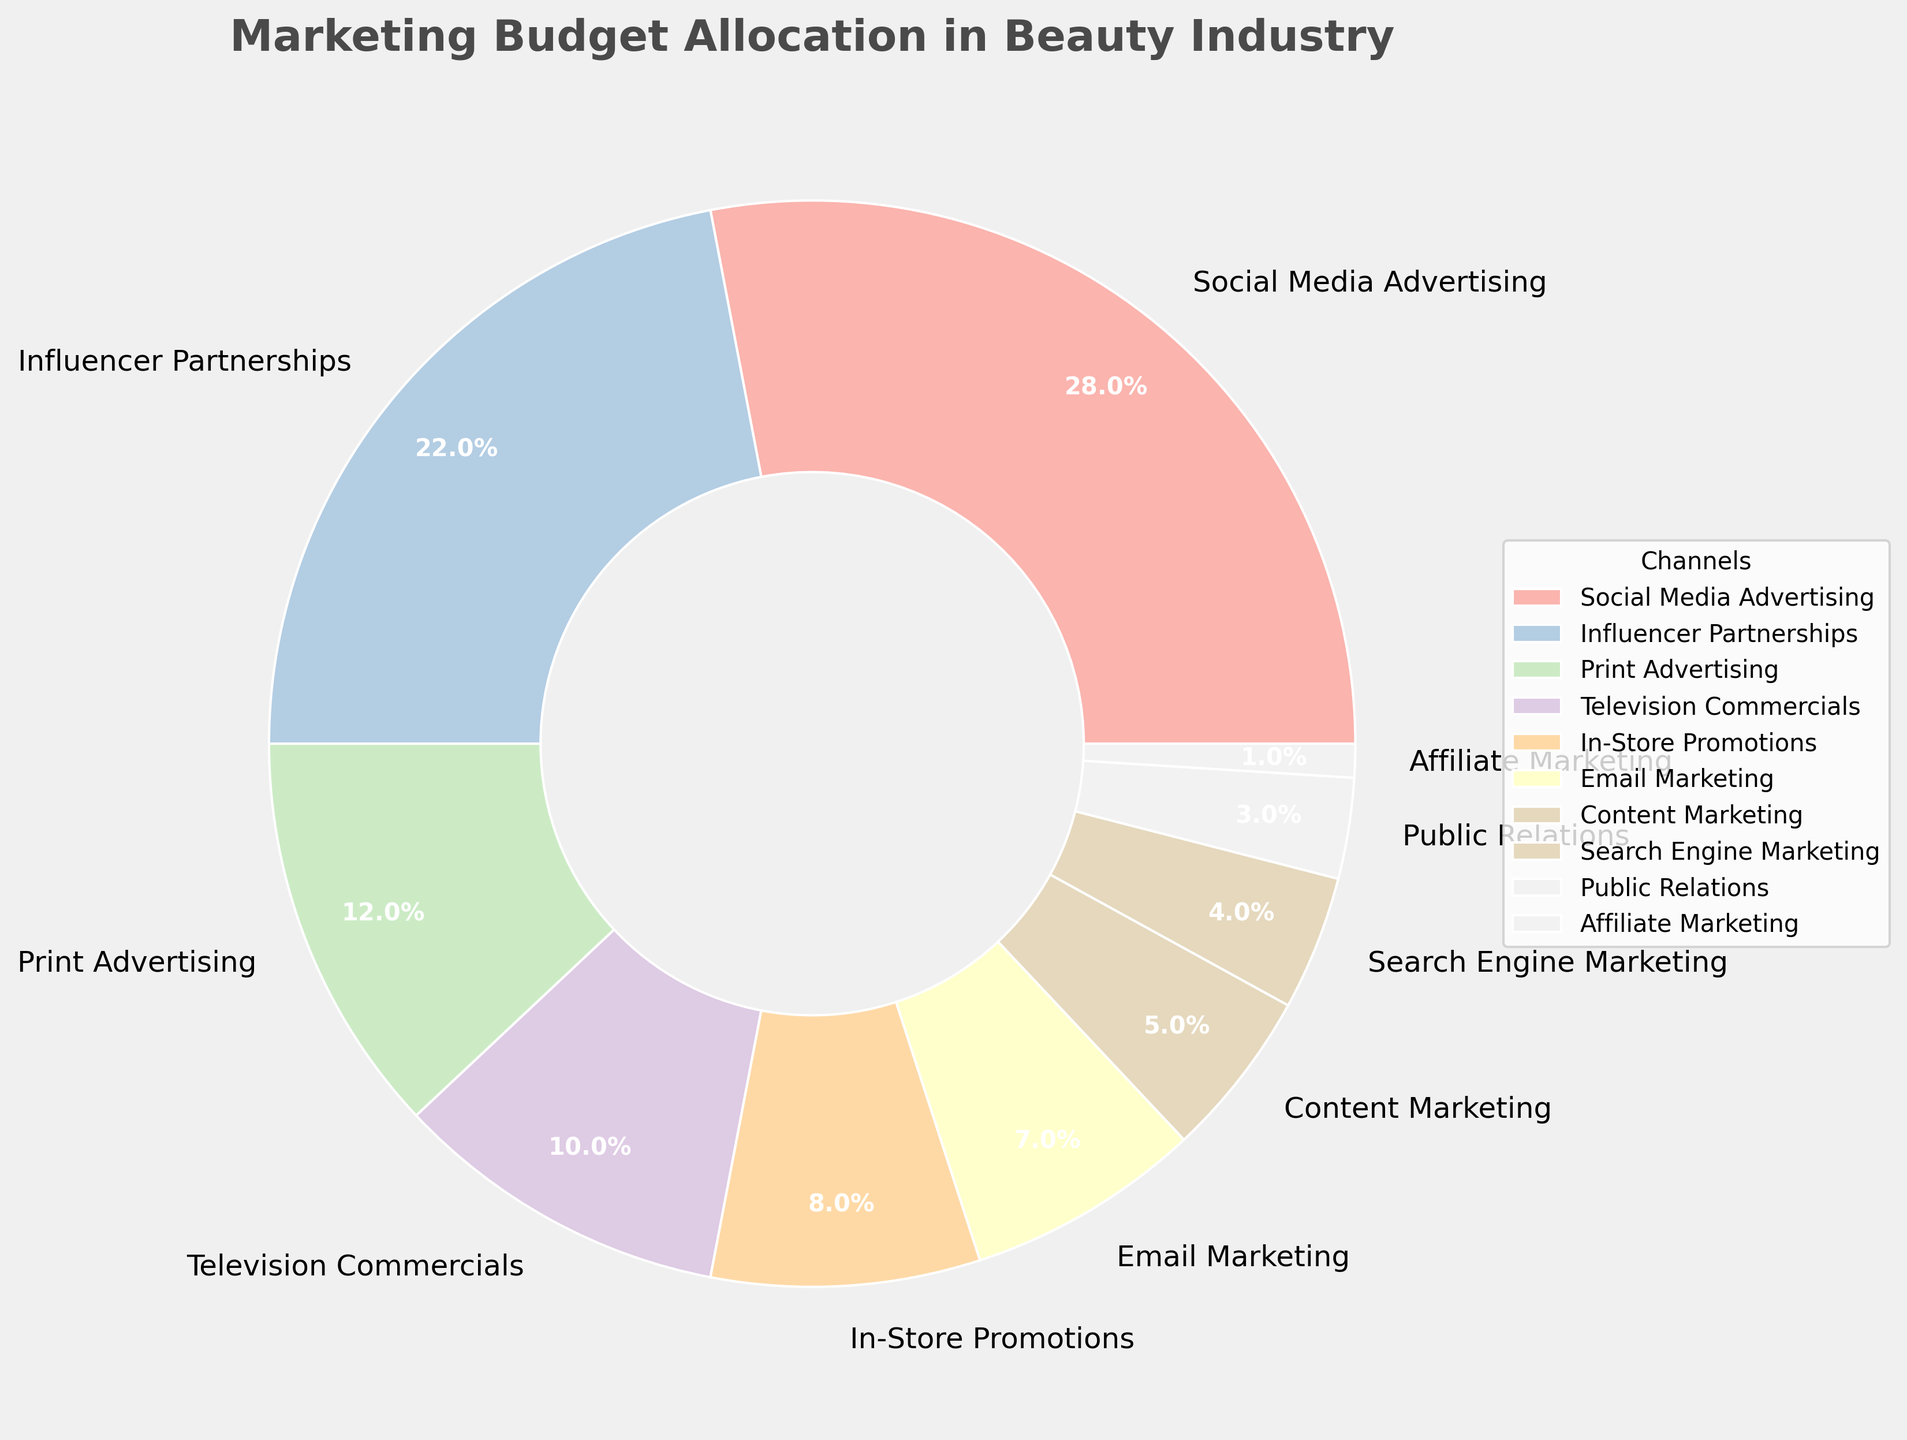Which promotional channel has the highest budget allocation? The promotional channel with the highest percentage in the pie chart is Social Media Advertising with 28%.
Answer: Social Media Advertising Which promotional channel has the lowest budget allocation? The promotional channel with the lowest percentage in the pie chart is Affiliate Marketing with 1%.
Answer: Affiliate Marketing What is the combined percentage for traditional advertising channels (Print Advertising and Television Commercials)? The percentage for Print Advertising is 12% and for Television Commercials is 10%. Summing them up gives 12% + 10% = 22%.
Answer: 22% How much more budget is allocated to Influencer Partnerships compared to In-Store Promotions? The percentage for Influencer Partnerships is 22% and for In-Store Promotions is 8%. The difference is 22% - 8% = 14%.
Answer: 14% Which channel, Content Marketing or Search Engine Marketing, has a higher budget allocation, and by how much? Content Marketing has 5%, and Search Engine Marketing has 4%. The difference is 5% - 4% = 1%. Hence, Content Marketing has a higher allocation by 1%.
Answer: Content Marketing by 1% What percentage of the marketing budget is allocated to digital channels (Social Media Advertising, Influencer Partnerships, Email Marketing, Content Marketing, Search Engine Marketing, and Affiliate Marketing)? Adding the percentages: 28% (Social Media Advertising) + 22% (Influencer Partnerships) + 7% (Email Marketing) + 5% (Content Marketing) + 4% (Search Engine Marketing) + 1% (Affiliate Marketing) = 67%.
Answer: 67% Are there more budget allocations for Digital Marketing channels compared to Traditional Marketing (Print Advertising, Television Commercials, In-Store Promotions, Public Relations)? Adding percentages for Digital Marketing (67%) and Traditional Marketing: 12% (Print Advertising) + 10% (Television Commercials) + 8% (In-Store Promotions) + 3% (Public Relations) = 33%. 67% > 33%, so more budget is allocated to Digital Marketing.
Answer: Yes What is the difference between the budget allocation for the highest and lowest channels? The highest allocation is 28% for Social Media Advertising, and the lowest is 1% for Affiliate Marketing. The difference is 28% - 1% = 27%.
Answer: 27% Which channels have budget allocations less than 10%? The channels with percentages less than 10% are Television Commercials (10%), In-Store Promotions (8%), Email Marketing (7%), Content Marketing (5%), Search Engine Marketing (4%), Public Relations (3%), and Affiliate Marketing (1%).
Answer: Television Commercials, In-Store Promotions, Email Marketing, Content Marketing, Search Engine Marketing, Public Relations, Affiliate Marketing 